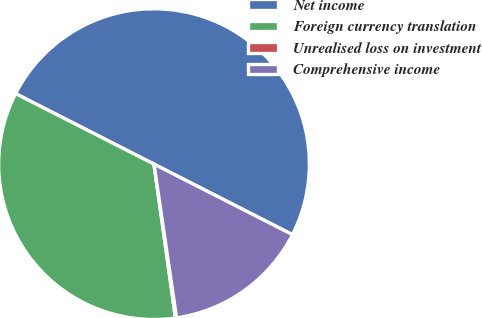Convert chart. <chart><loc_0><loc_0><loc_500><loc_500><pie_chart><fcel>Net income<fcel>Foreign currency translation<fcel>Unrealised loss on investment<fcel>Comprehensive income<nl><fcel>50.0%<fcel>34.7%<fcel>0.12%<fcel>15.18%<nl></chart> 